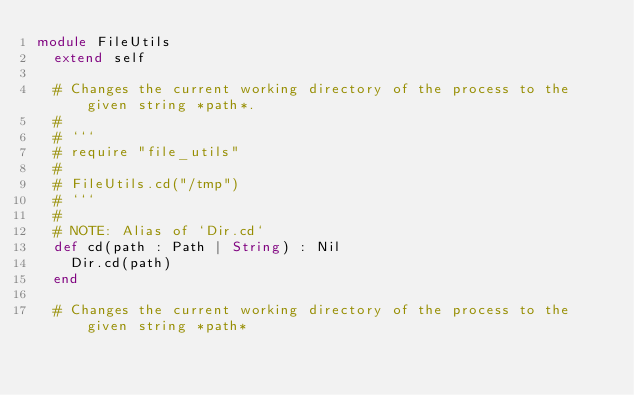Convert code to text. <code><loc_0><loc_0><loc_500><loc_500><_Crystal_>module FileUtils
  extend self

  # Changes the current working directory of the process to the given string *path*.
  #
  # ```
  # require "file_utils"
  #
  # FileUtils.cd("/tmp")
  # ```
  #
  # NOTE: Alias of `Dir.cd`
  def cd(path : Path | String) : Nil
    Dir.cd(path)
  end

  # Changes the current working directory of the process to the given string *path*</code> 